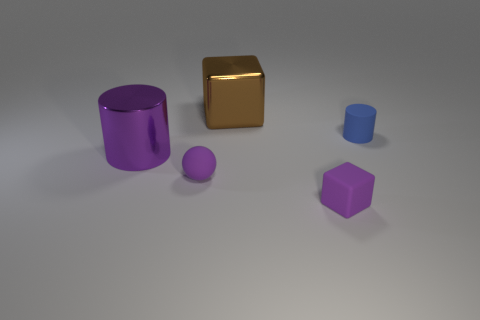Is the size of the blue cylinder the same as the purple metallic thing?
Keep it short and to the point. No. Is there a purple object that has the same material as the tiny cube?
Your answer should be very brief. Yes. There is a metal thing that is the same color as the tiny block; what size is it?
Offer a terse response. Large. How many tiny rubber things are both right of the purple matte sphere and in front of the purple metal thing?
Provide a succinct answer. 1. There is a purple object on the right side of the purple sphere; what is it made of?
Make the answer very short. Rubber. How many rubber spheres are the same color as the large metal cylinder?
Give a very brief answer. 1. There is a blue cylinder that is the same material as the tiny purple block; what size is it?
Your answer should be compact. Small. How many objects are purple blocks or purple matte objects?
Keep it short and to the point. 2. There is a cylinder on the left side of the tiny blue cylinder; what is its color?
Make the answer very short. Purple. There is a purple rubber object that is the same shape as the large brown metallic object; what size is it?
Give a very brief answer. Small. 